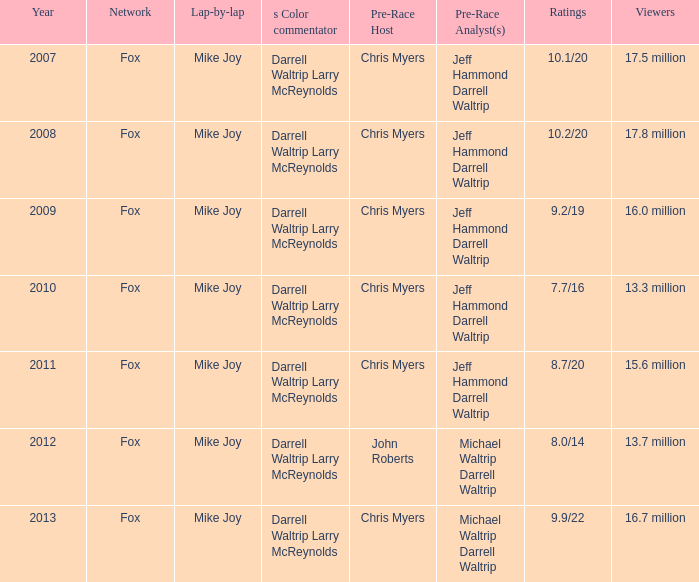Which network attracts 1 Fox. 